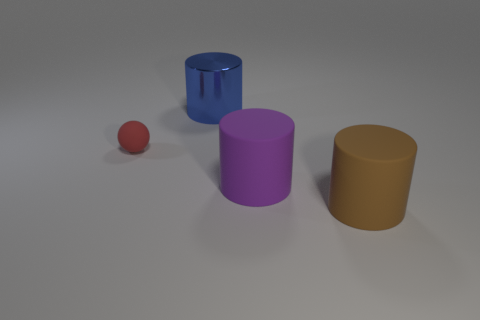Add 1 big blue shiny cylinders. How many objects exist? 5 Subtract all purple cylinders. How many cylinders are left? 2 Subtract all large shiny cylinders. How many cylinders are left? 2 Subtract 0 yellow balls. How many objects are left? 4 Subtract all balls. How many objects are left? 3 Subtract 2 cylinders. How many cylinders are left? 1 Subtract all blue balls. Subtract all yellow cylinders. How many balls are left? 1 Subtract all gray blocks. How many yellow spheres are left? 0 Subtract all large metallic things. Subtract all gray spheres. How many objects are left? 3 Add 2 red matte objects. How many red matte objects are left? 3 